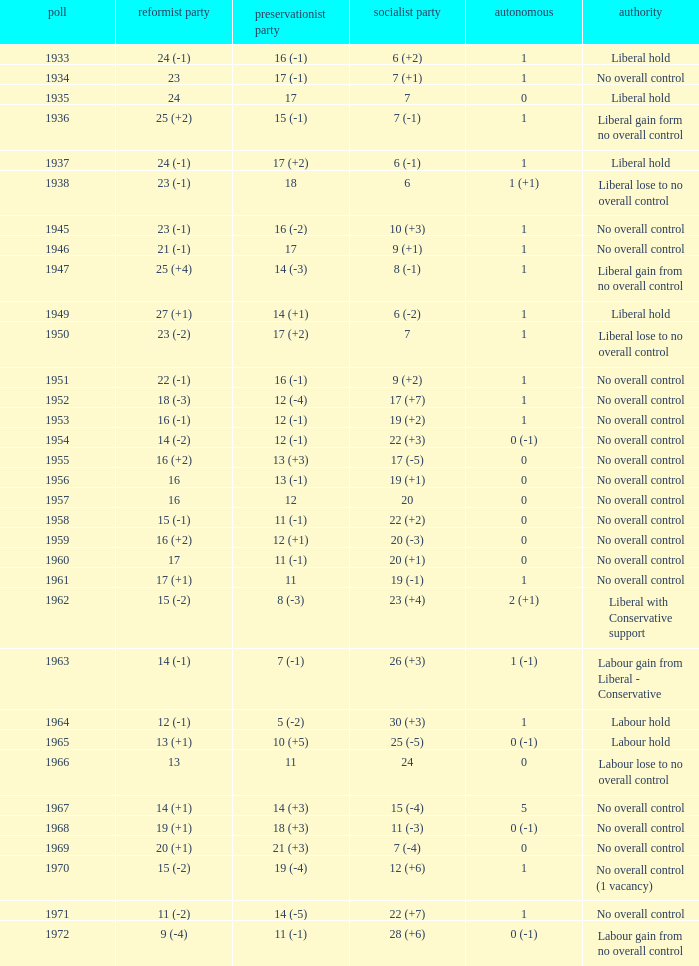Who was in control the year that Labour Party won 12 (+6) seats? No overall control (1 vacancy). 